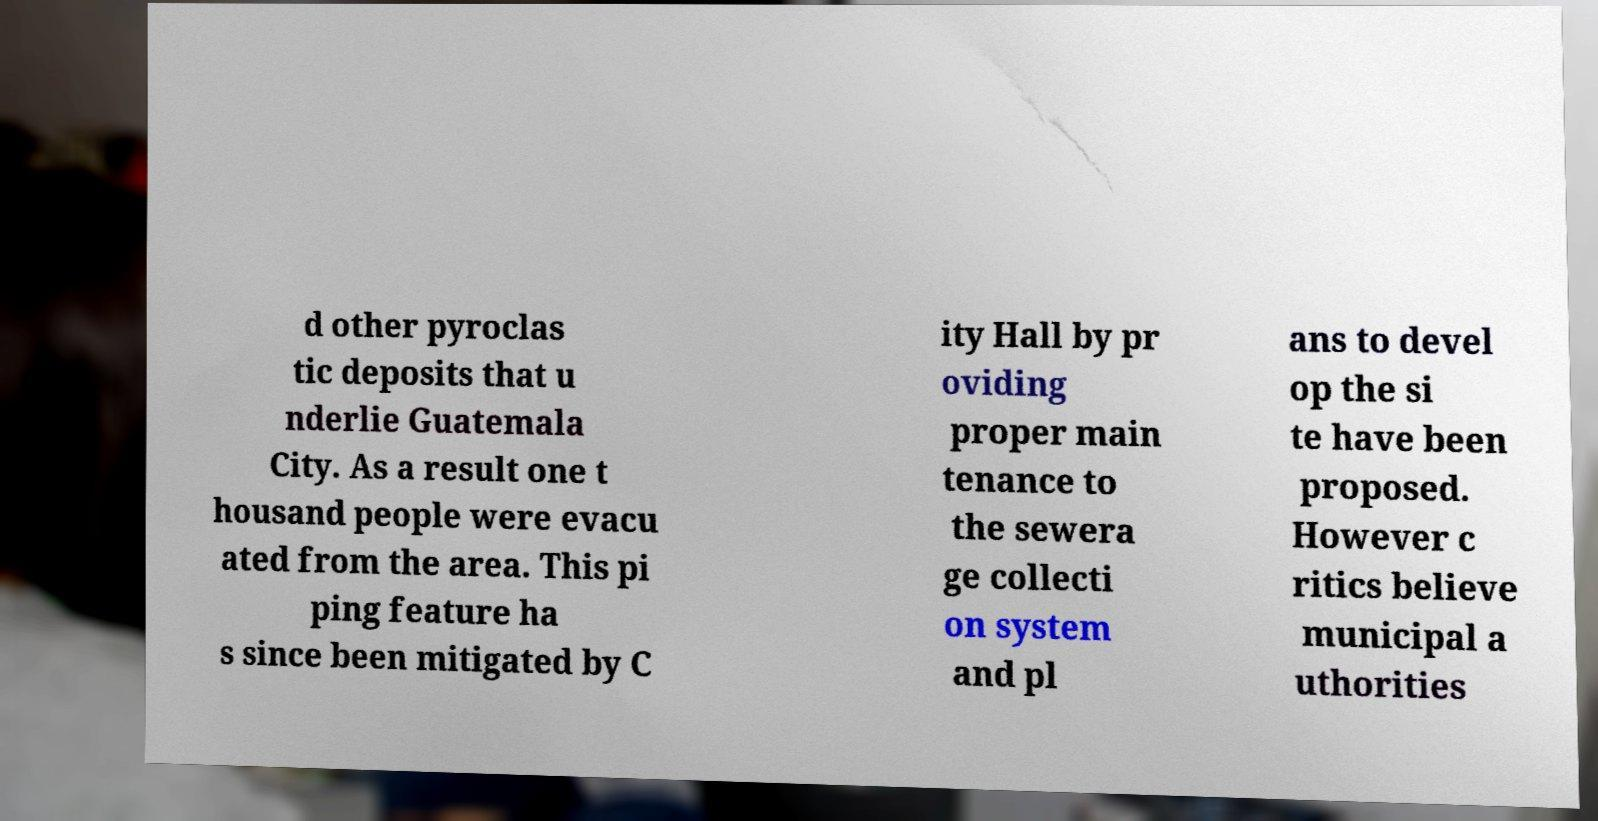Please identify and transcribe the text found in this image. d other pyroclas tic deposits that u nderlie Guatemala City. As a result one t housand people were evacu ated from the area. This pi ping feature ha s since been mitigated by C ity Hall by pr oviding proper main tenance to the sewera ge collecti on system and pl ans to devel op the si te have been proposed. However c ritics believe municipal a uthorities 